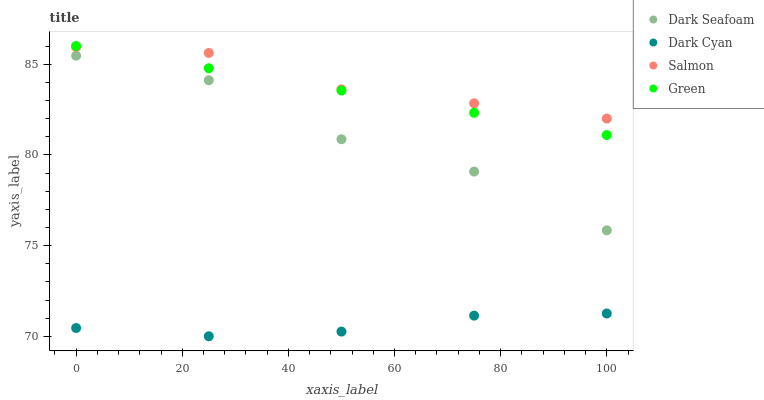Does Dark Cyan have the minimum area under the curve?
Answer yes or no. Yes. Does Salmon have the maximum area under the curve?
Answer yes or no. Yes. Does Green have the minimum area under the curve?
Answer yes or no. No. Does Green have the maximum area under the curve?
Answer yes or no. No. Is Green the smoothest?
Answer yes or no. Yes. Is Dark Seafoam the roughest?
Answer yes or no. Yes. Is Dark Seafoam the smoothest?
Answer yes or no. No. Is Green the roughest?
Answer yes or no. No. Does Dark Cyan have the lowest value?
Answer yes or no. Yes. Does Green have the lowest value?
Answer yes or no. No. Does Green have the highest value?
Answer yes or no. Yes. Does Dark Seafoam have the highest value?
Answer yes or no. No. Is Dark Seafoam less than Salmon?
Answer yes or no. Yes. Is Salmon greater than Dark Cyan?
Answer yes or no. Yes. Does Green intersect Salmon?
Answer yes or no. Yes. Is Green less than Salmon?
Answer yes or no. No. Is Green greater than Salmon?
Answer yes or no. No. Does Dark Seafoam intersect Salmon?
Answer yes or no. No. 